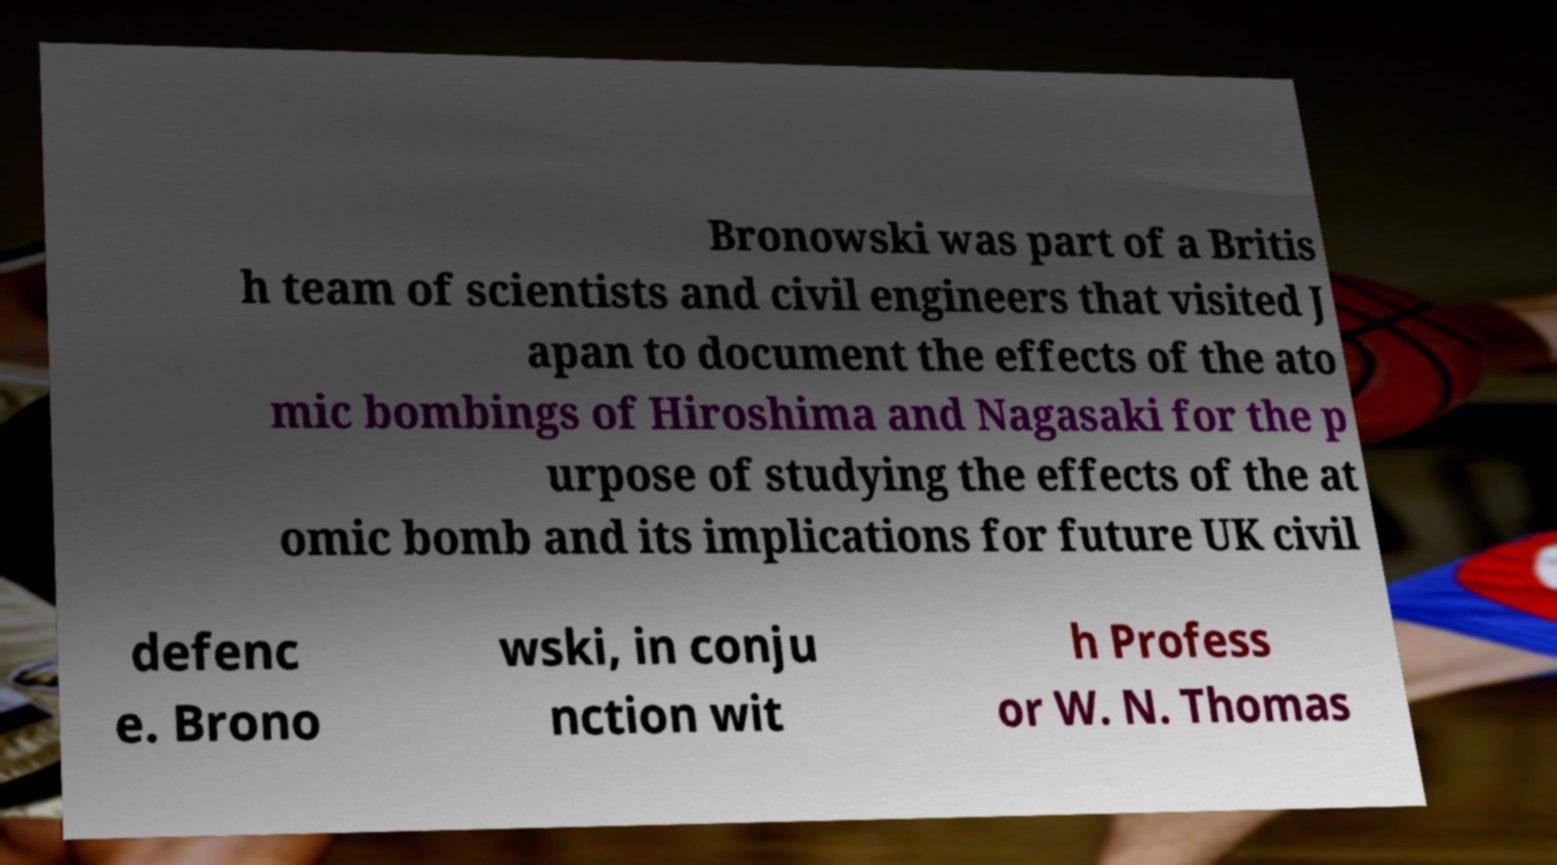What messages or text are displayed in this image? I need them in a readable, typed format. Bronowski was part of a Britis h team of scientists and civil engineers that visited J apan to document the effects of the ato mic bombings of Hiroshima and Nagasaki for the p urpose of studying the effects of the at omic bomb and its implications for future UK civil defenc e. Brono wski, in conju nction wit h Profess or W. N. Thomas 